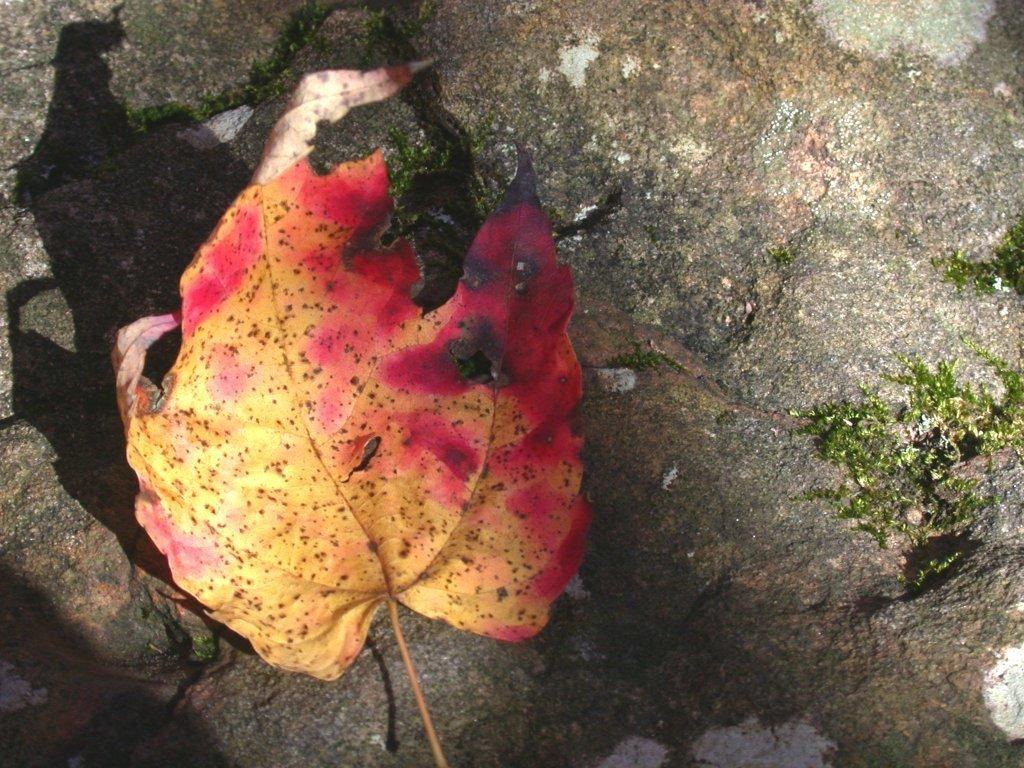What type of plant material is visible in the image? There is a leaf and grass in the image. Can you describe the terrain in the image? The terrain includes grass and a rock in the background. What type of copper branch can be seen in the image? There is no copper branch present in the image. What type of shock can be seen in the image? There is no shock present in the image. 